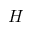<formula> <loc_0><loc_0><loc_500><loc_500>H</formula> 